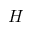<formula> <loc_0><loc_0><loc_500><loc_500>H</formula> 